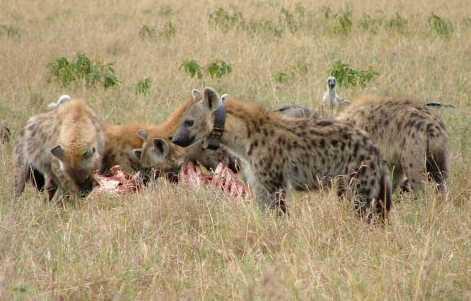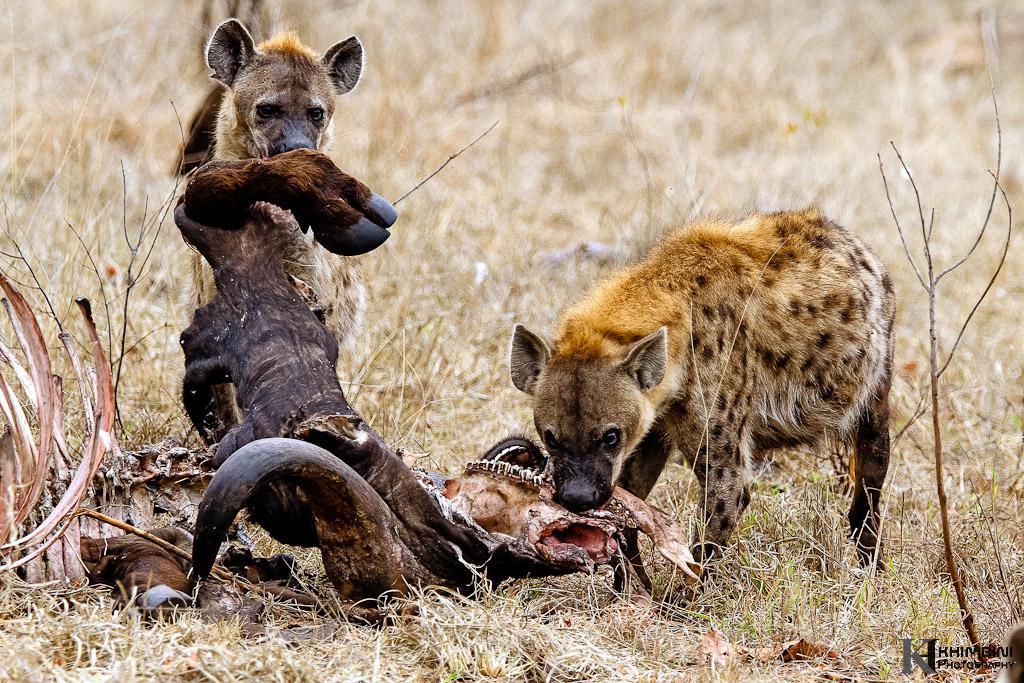The first image is the image on the left, the second image is the image on the right. Examine the images to the left and right. Is the description "In the image to the right, there are at least four hyenas." accurate? Answer yes or no. No. The first image is the image on the left, the second image is the image on the right. Examine the images to the left and right. Is the description "Multiple hyena are standing behind a carcass with the horn of a hooved animal in front of them, including a leftward-turned hyena with its mouth lowered to the carcass." accurate? Answer yes or no. Yes. 